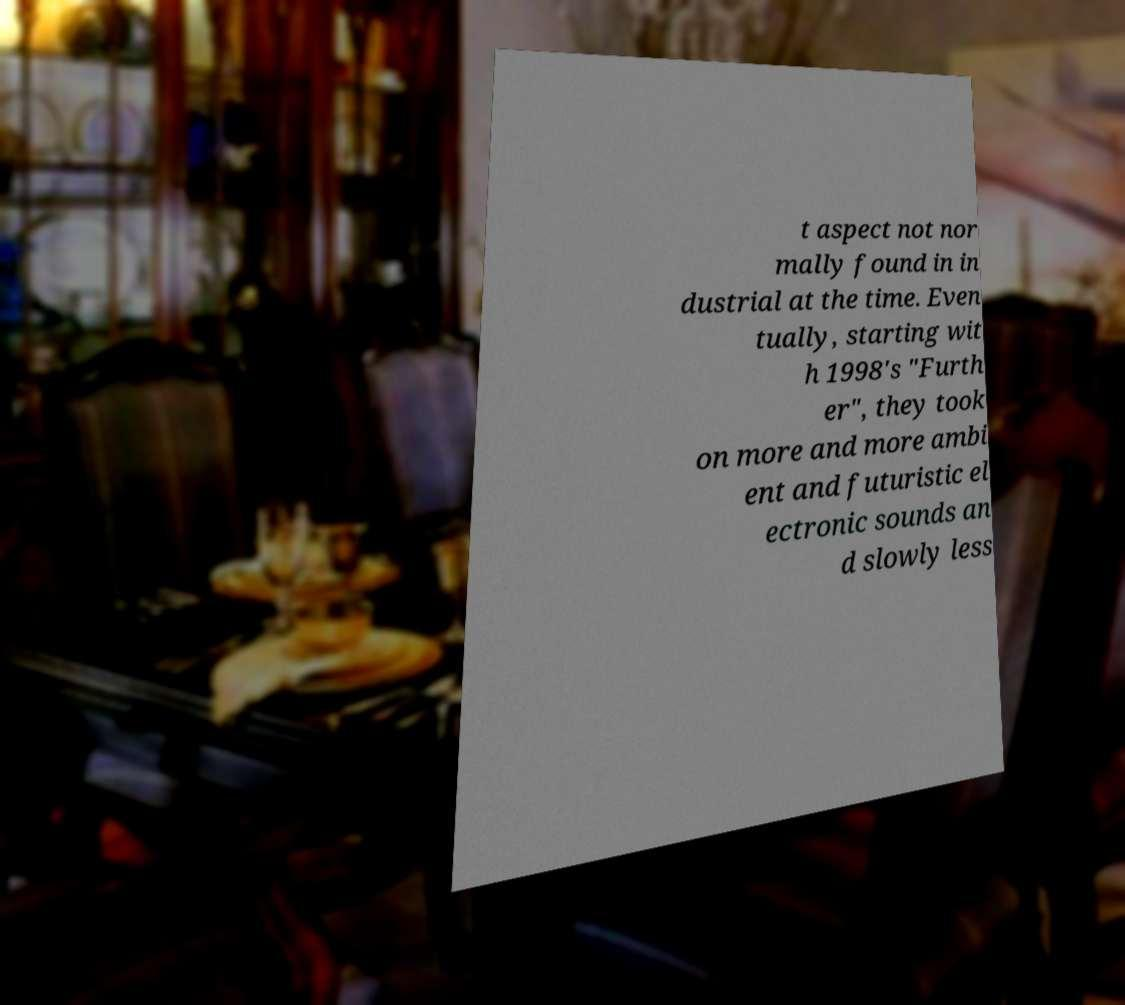Could you assist in decoding the text presented in this image and type it out clearly? t aspect not nor mally found in in dustrial at the time. Even tually, starting wit h 1998's "Furth er", they took on more and more ambi ent and futuristic el ectronic sounds an d slowly less 